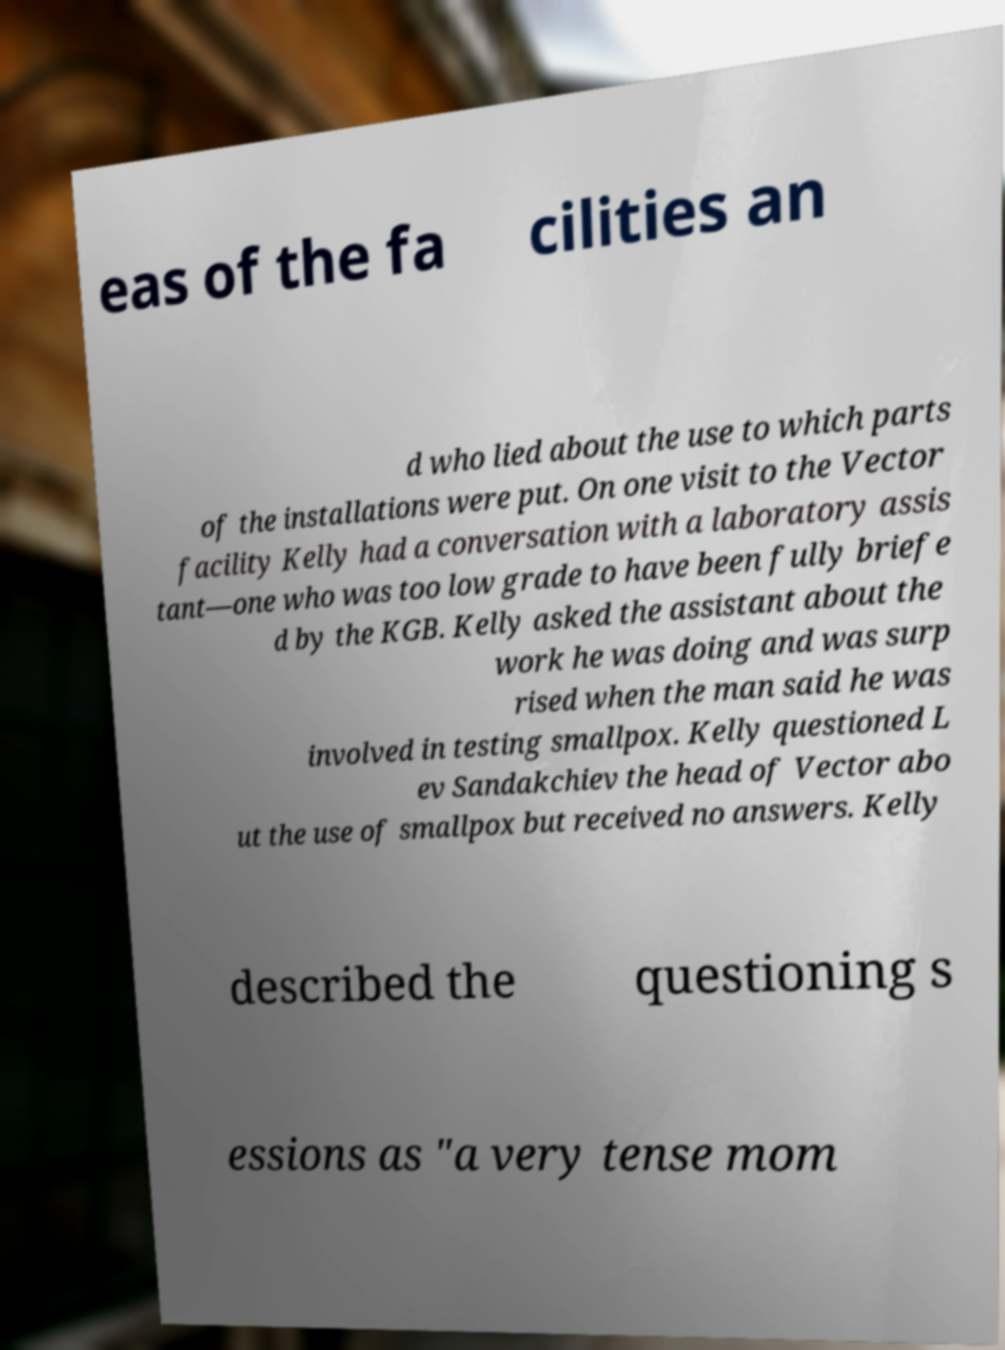Could you extract and type out the text from this image? eas of the fa cilities an d who lied about the use to which parts of the installations were put. On one visit to the Vector facility Kelly had a conversation with a laboratory assis tant—one who was too low grade to have been fully briefe d by the KGB. Kelly asked the assistant about the work he was doing and was surp rised when the man said he was involved in testing smallpox. Kelly questioned L ev Sandakchiev the head of Vector abo ut the use of smallpox but received no answers. Kelly described the questioning s essions as "a very tense mom 